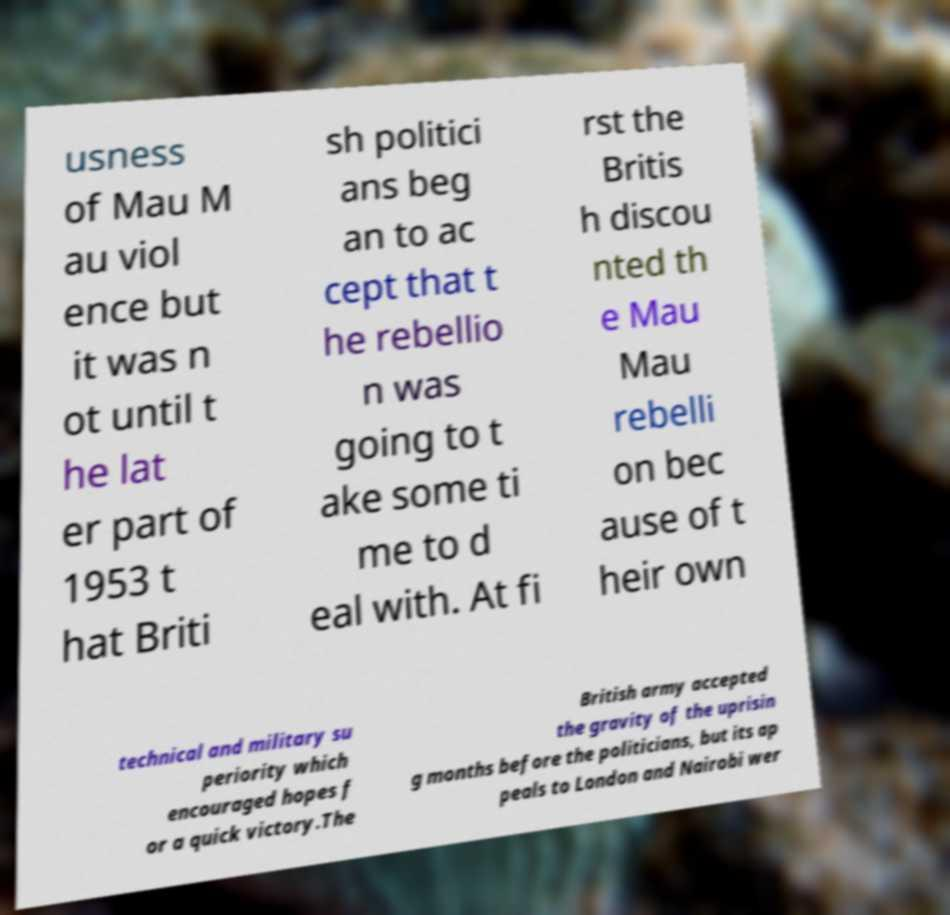Could you assist in decoding the text presented in this image and type it out clearly? usness of Mau M au viol ence but it was n ot until t he lat er part of 1953 t hat Briti sh politici ans beg an to ac cept that t he rebellio n was going to t ake some ti me to d eal with. At fi rst the Britis h discou nted th e Mau Mau rebelli on bec ause of t heir own technical and military su periority which encouraged hopes f or a quick victory.The British army accepted the gravity of the uprisin g months before the politicians, but its ap peals to London and Nairobi wer 